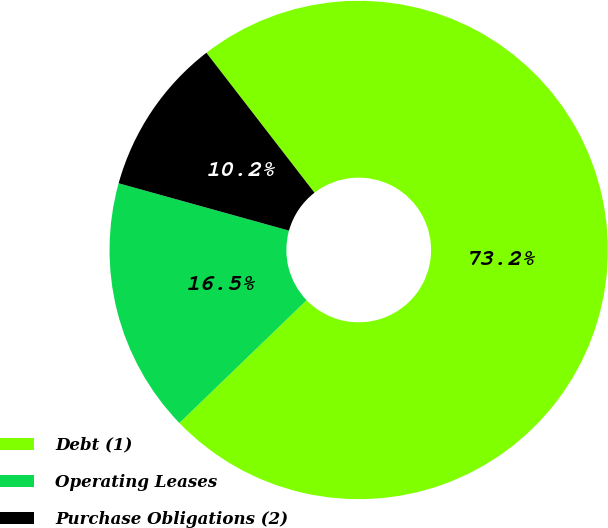Convert chart. <chart><loc_0><loc_0><loc_500><loc_500><pie_chart><fcel>Debt (1)<fcel>Operating Leases<fcel>Purchase Obligations (2)<nl><fcel>73.25%<fcel>16.53%<fcel>10.22%<nl></chart> 